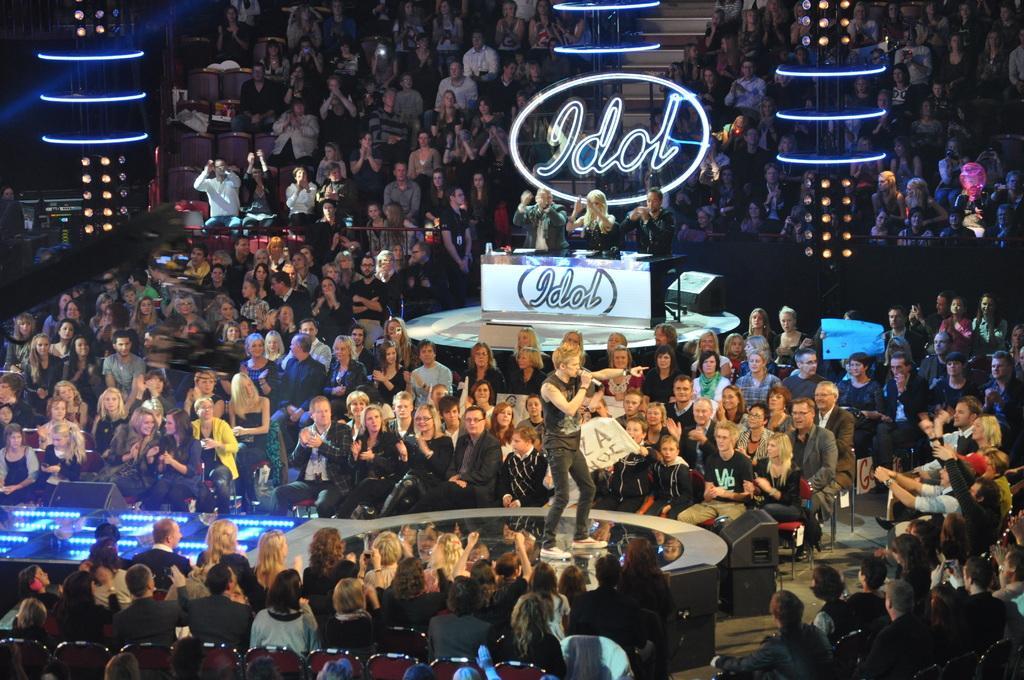Could you give a brief overview of what you see in this image? Here people are sitting on the chairs, this is desk, a man is standing holding microphone. 